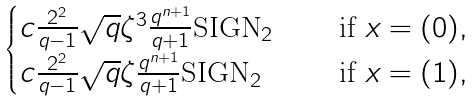<formula> <loc_0><loc_0><loc_500><loc_500>\begin{cases} c \frac { 2 ^ { 2 } } { q - 1 } \sqrt { q } \zeta ^ { 3 } \frac { q ^ { n + 1 } } { q + 1 } \text {SIGN} _ { 2 } & \quad \text { if } x = ( 0 ) , \\ c \frac { 2 ^ { 2 } } { q - 1 } \sqrt { q } \zeta \frac { q ^ { n + 1 } } { q + 1 } \text {SIGN} _ { 2 } & \quad \text { if } x = ( 1 ) , \end{cases}</formula> 